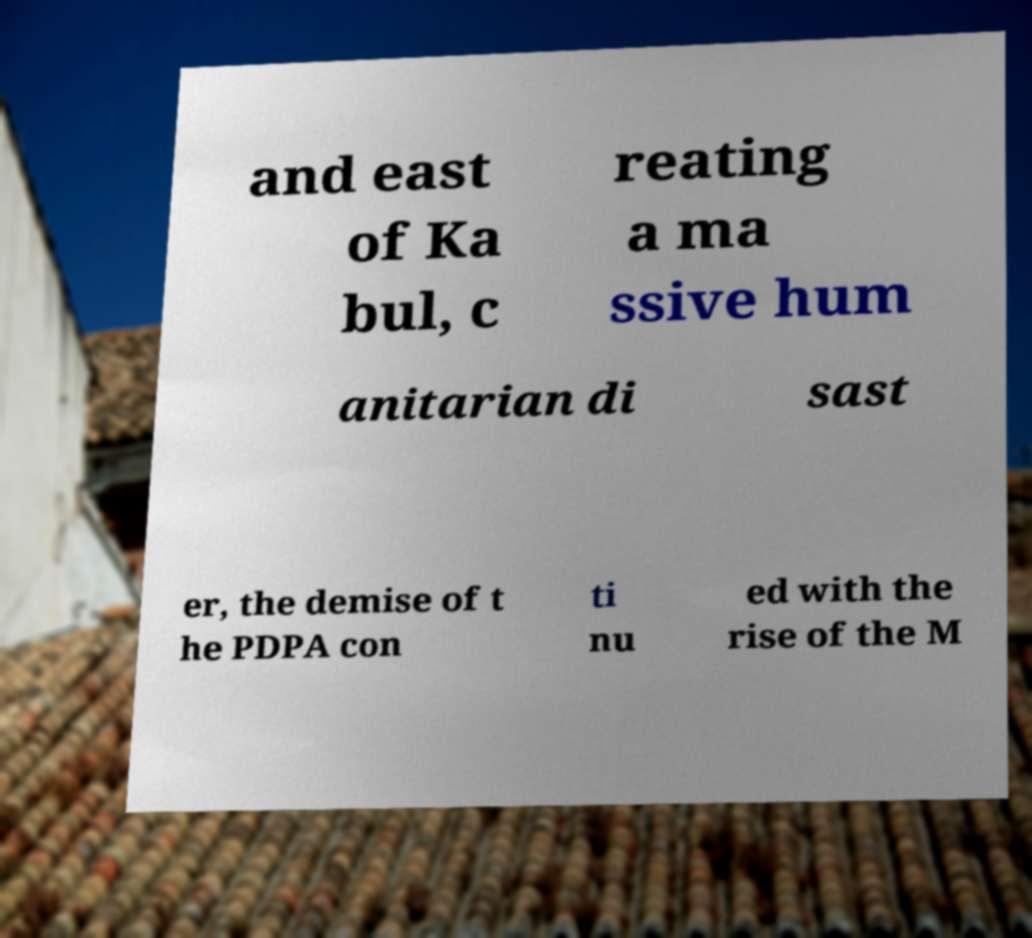Could you assist in decoding the text presented in this image and type it out clearly? and east of Ka bul, c reating a ma ssive hum anitarian di sast er, the demise of t he PDPA con ti nu ed with the rise of the M 